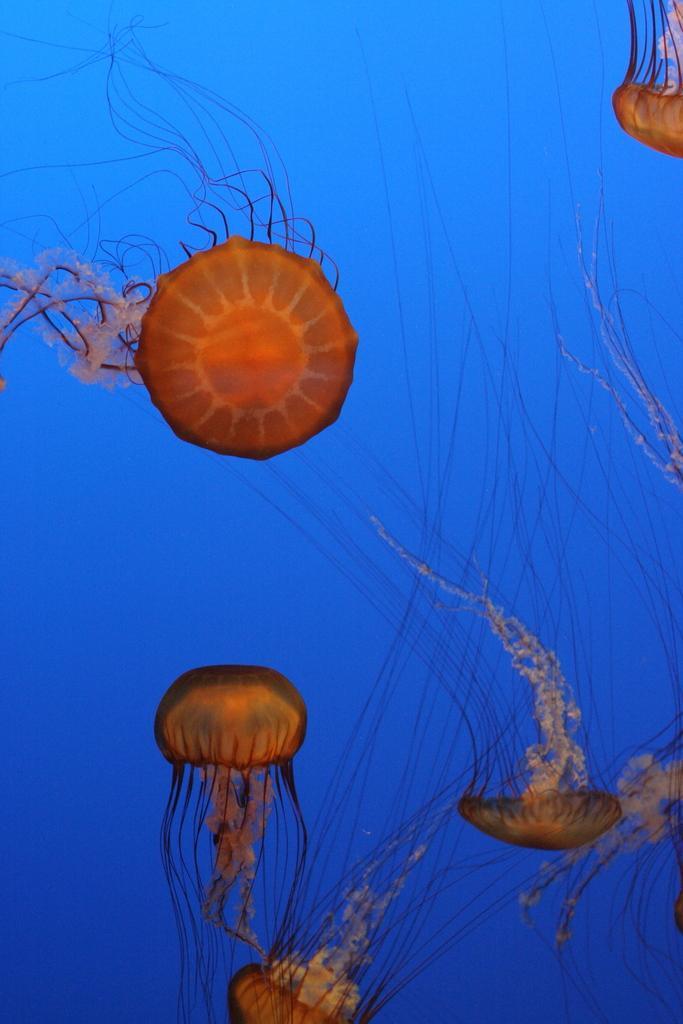Describe this image in one or two sentences. In this picture I can see there are few jelly fishes swimming in the water. 